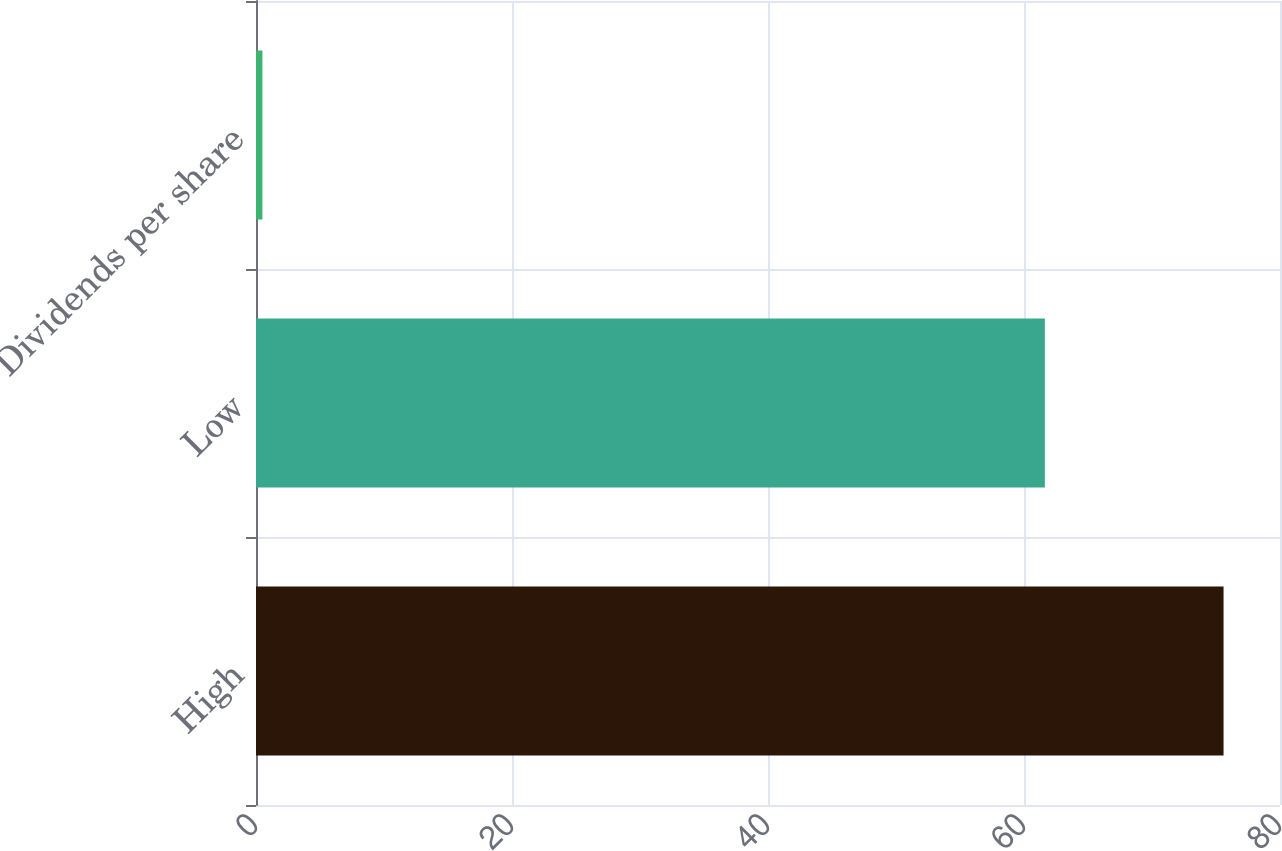<chart> <loc_0><loc_0><loc_500><loc_500><bar_chart><fcel>High<fcel>Low<fcel>Dividends per share<nl><fcel>75.59<fcel>61.63<fcel>0.5<nl></chart> 